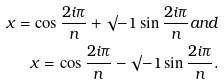<formula> <loc_0><loc_0><loc_500><loc_500>x = \cos { \frac { 2 i \pi } { n } } + \surd { - 1 } \sin { \frac { 2 i \pi } { n } } a n d \\ x = \cos { \frac { 2 i \pi } { n } } - \surd { - 1 } \sin { \frac { 2 i \pi } { n } } .</formula> 